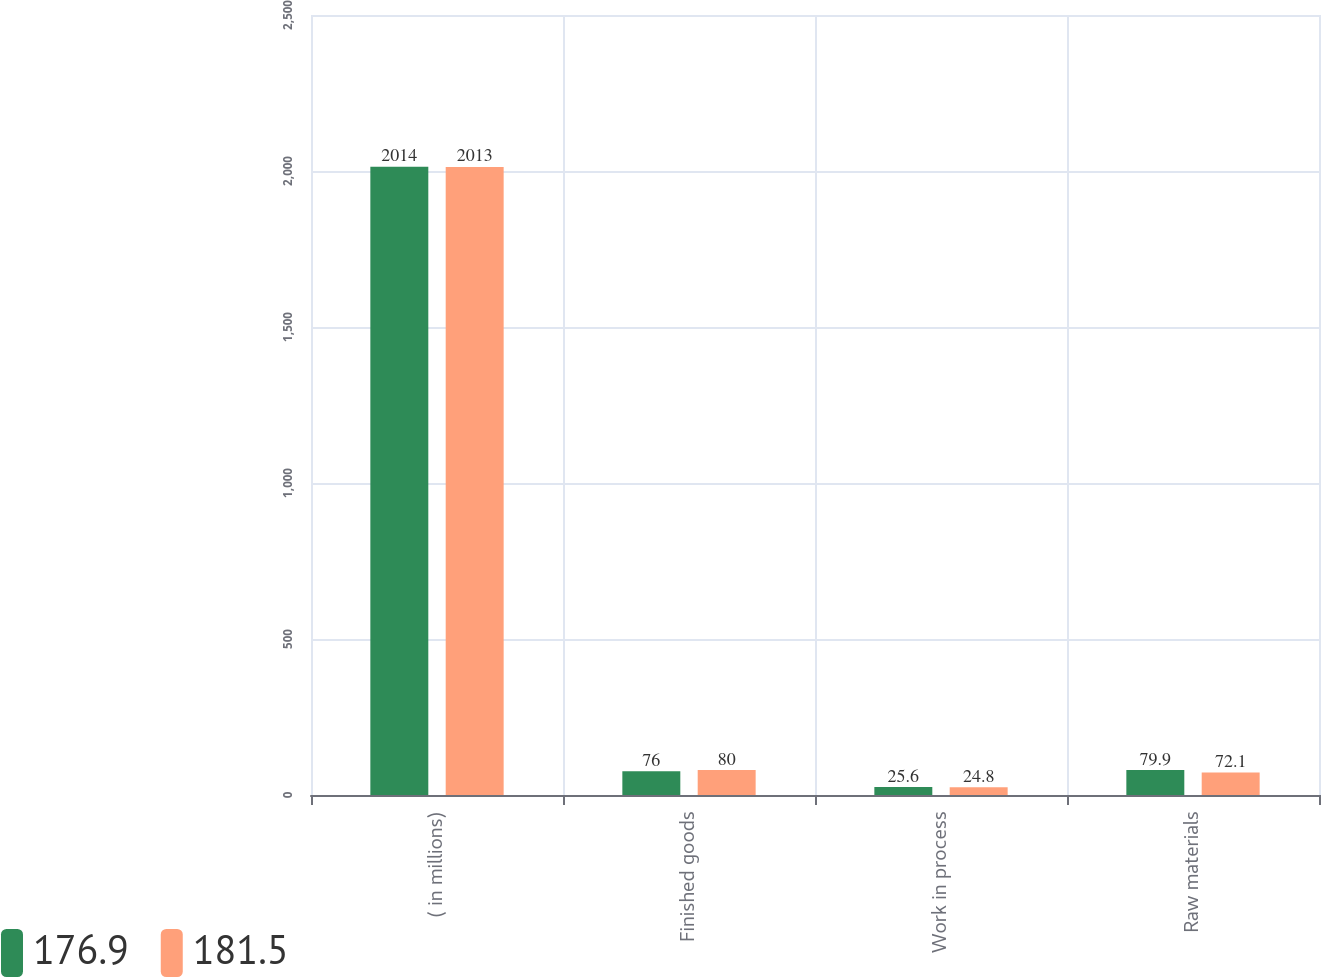<chart> <loc_0><loc_0><loc_500><loc_500><stacked_bar_chart><ecel><fcel>( in millions)<fcel>Finished goods<fcel>Work in process<fcel>Raw materials<nl><fcel>176.9<fcel>2014<fcel>76<fcel>25.6<fcel>79.9<nl><fcel>181.5<fcel>2013<fcel>80<fcel>24.8<fcel>72.1<nl></chart> 